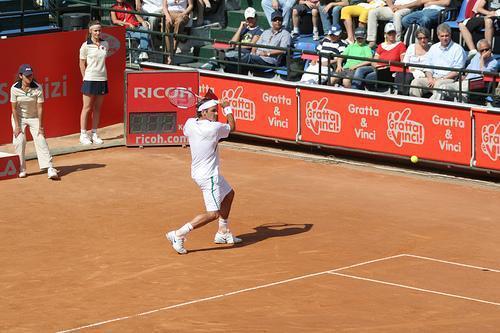How many people are visible?
Give a very brief answer. 5. How many elephants are visible?
Give a very brief answer. 0. 